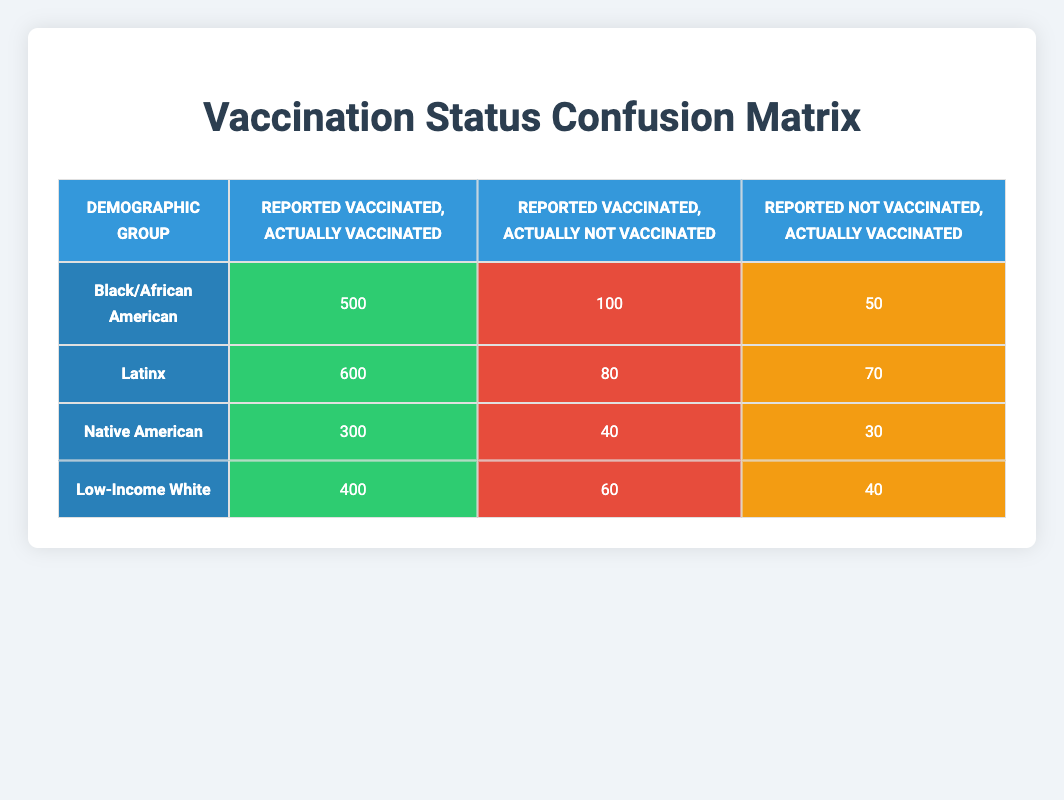What is the total count of true positives for the Black/African American demographic? The true positive count for the Black/African American demographic is 500, as indicated in the corresponding cell in the table.
Answer: 500 How many individuals from the Latinx demographic reported being vaccinated but were actually not vaccinated? The Latinx demographic has 80 reported as vaccinated but were actually not vaccinated. This is shown in the respective cell of the table.
Answer: 80 What is the total count of individuals who were actually vaccinated across all demographic groups? To find this, we sum the true positives from each group: 500 (Black/African American) + 600 (Latinx) + 300 (Native American) + 400 (Low-Income White) = 1800.
Answer: 1800 Is it true that the Native American demographic has a higher number of reported vaccinated individuals than those who were actually not vaccinated? For the Native American group, 300 reported vaccinated and 40 reported vaccinated but actually not vaccinated. Since 300 is greater than 40, the statement is true.
Answer: Yes What is the overall number of individuals who reported being vaccinated but were actually not vaccinated across all groups? We sum the false positives from each group: 100 (Black/African American) + 80 (Latinx) + 40 (Native American) + 60 (Low-Income White) = 280.
Answer: 280 How does the count of false negatives in the Latinx demographic compare to that of the Black/African American demographic? The Latinx group has 70 false negatives while the Black/African American group has 50. Since 70 is greater than 50, there are more false negatives in the Latinx group.
Answer: More in Latinx What is the average number of true positives among all demographic groups? The total true positives sum up to 500 + 600 + 300 + 400 = 1800. There are four demographic groups, so the average is 1800 / 4 = 450.
Answer: 450 What is the total of individuals who actually were vaccinated but reported as not vaccinated for Low-Income White? From the table, the Low-Income White group has 40 reported as not vaccinated but actually vaccinated. This figure is directly visible in the table.
Answer: 40 What percentage of the Black/African American demographic is accurately reported as vaccinated? The accurate reports are the true positives (500) from the total of true positives (500) and false negatives (50). Thus, the percentage is (500 / (500 + 50)) * 100 = 90.91%.
Answer: 90.91% 